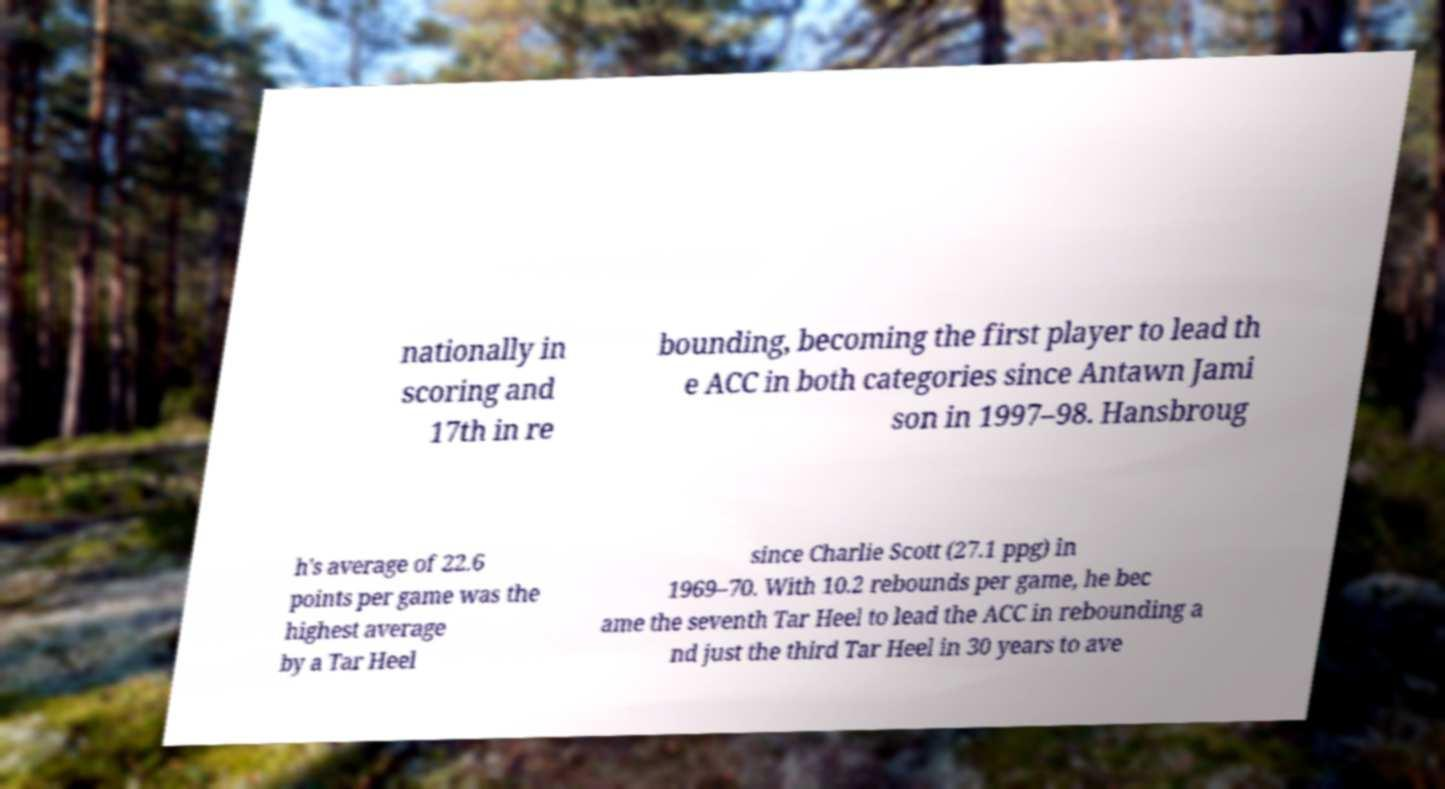For documentation purposes, I need the text within this image transcribed. Could you provide that? nationally in scoring and 17th in re bounding, becoming the first player to lead th e ACC in both categories since Antawn Jami son in 1997–98. Hansbroug h's average of 22.6 points per game was the highest average by a Tar Heel since Charlie Scott (27.1 ppg) in 1969–70. With 10.2 rebounds per game, he bec ame the seventh Tar Heel to lead the ACC in rebounding a nd just the third Tar Heel in 30 years to ave 